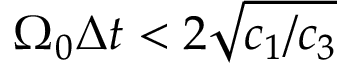Convert formula to latex. <formula><loc_0><loc_0><loc_500><loc_500>\Omega _ { 0 } \Delta { t } < 2 \sqrt { c _ { 1 } / c _ { 3 } }</formula> 